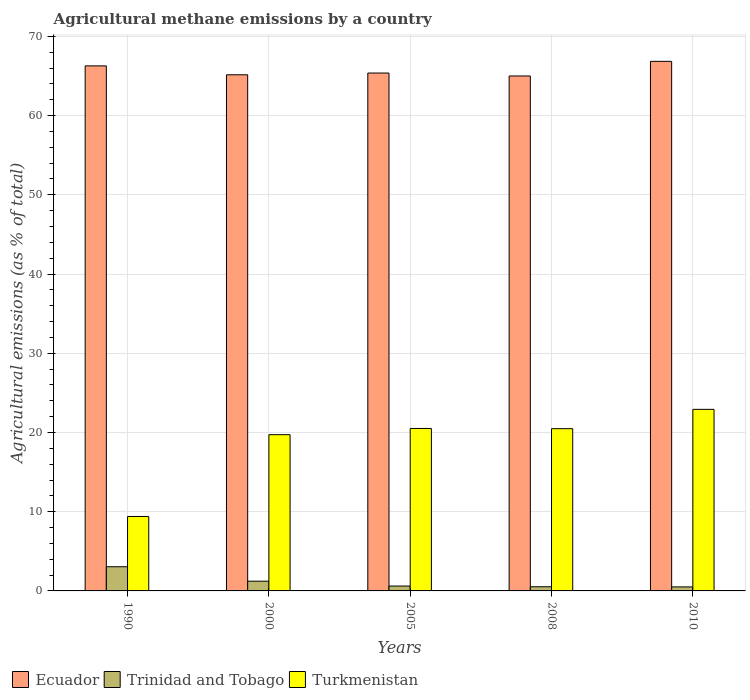How many groups of bars are there?
Offer a very short reply. 5. Are the number of bars on each tick of the X-axis equal?
Your response must be concise. Yes. What is the amount of agricultural methane emitted in Turkmenistan in 1990?
Your answer should be very brief. 9.4. Across all years, what is the maximum amount of agricultural methane emitted in Turkmenistan?
Ensure brevity in your answer.  22.92. Across all years, what is the minimum amount of agricultural methane emitted in Trinidad and Tobago?
Your answer should be very brief. 0.51. In which year was the amount of agricultural methane emitted in Trinidad and Tobago maximum?
Offer a very short reply. 1990. What is the total amount of agricultural methane emitted in Trinidad and Tobago in the graph?
Your answer should be compact. 5.93. What is the difference between the amount of agricultural methane emitted in Trinidad and Tobago in 2000 and that in 2008?
Keep it short and to the point. 0.7. What is the difference between the amount of agricultural methane emitted in Trinidad and Tobago in 2000 and the amount of agricultural methane emitted in Turkmenistan in 2005?
Provide a succinct answer. -19.28. What is the average amount of agricultural methane emitted in Trinidad and Tobago per year?
Provide a succinct answer. 1.19. In the year 2008, what is the difference between the amount of agricultural methane emitted in Turkmenistan and amount of agricultural methane emitted in Trinidad and Tobago?
Make the answer very short. 19.95. What is the ratio of the amount of agricultural methane emitted in Turkmenistan in 2000 to that in 2010?
Your answer should be compact. 0.86. Is the amount of agricultural methane emitted in Trinidad and Tobago in 2008 less than that in 2010?
Your response must be concise. No. What is the difference between the highest and the second highest amount of agricultural methane emitted in Turkmenistan?
Offer a very short reply. 2.41. What is the difference between the highest and the lowest amount of agricultural methane emitted in Ecuador?
Provide a succinct answer. 1.85. Is the sum of the amount of agricultural methane emitted in Trinidad and Tobago in 1990 and 2000 greater than the maximum amount of agricultural methane emitted in Turkmenistan across all years?
Your answer should be very brief. No. What does the 3rd bar from the left in 2000 represents?
Your response must be concise. Turkmenistan. What does the 3rd bar from the right in 2000 represents?
Keep it short and to the point. Ecuador. Is it the case that in every year, the sum of the amount of agricultural methane emitted in Trinidad and Tobago and amount of agricultural methane emitted in Ecuador is greater than the amount of agricultural methane emitted in Turkmenistan?
Provide a short and direct response. Yes. How many bars are there?
Your response must be concise. 15. How many years are there in the graph?
Your answer should be very brief. 5. What is the difference between two consecutive major ticks on the Y-axis?
Your answer should be very brief. 10. Are the values on the major ticks of Y-axis written in scientific E-notation?
Your response must be concise. No. Does the graph contain any zero values?
Offer a very short reply. No. Does the graph contain grids?
Provide a short and direct response. Yes. How many legend labels are there?
Give a very brief answer. 3. What is the title of the graph?
Your response must be concise. Agricultural methane emissions by a country. Does "Tonga" appear as one of the legend labels in the graph?
Provide a succinct answer. No. What is the label or title of the Y-axis?
Keep it short and to the point. Agricultural emissions (as % of total). What is the Agricultural emissions (as % of total) of Ecuador in 1990?
Offer a very short reply. 66.27. What is the Agricultural emissions (as % of total) in Trinidad and Tobago in 1990?
Your answer should be compact. 3.05. What is the Agricultural emissions (as % of total) in Turkmenistan in 1990?
Keep it short and to the point. 9.4. What is the Agricultural emissions (as % of total) in Ecuador in 2000?
Your answer should be compact. 65.15. What is the Agricultural emissions (as % of total) of Trinidad and Tobago in 2000?
Ensure brevity in your answer.  1.23. What is the Agricultural emissions (as % of total) of Turkmenistan in 2000?
Ensure brevity in your answer.  19.72. What is the Agricultural emissions (as % of total) in Ecuador in 2005?
Provide a short and direct response. 65.37. What is the Agricultural emissions (as % of total) in Trinidad and Tobago in 2005?
Provide a succinct answer. 0.62. What is the Agricultural emissions (as % of total) of Turkmenistan in 2005?
Give a very brief answer. 20.51. What is the Agricultural emissions (as % of total) in Ecuador in 2008?
Your answer should be very brief. 65. What is the Agricultural emissions (as % of total) in Trinidad and Tobago in 2008?
Offer a terse response. 0.53. What is the Agricultural emissions (as % of total) of Turkmenistan in 2008?
Offer a very short reply. 20.48. What is the Agricultural emissions (as % of total) of Ecuador in 2010?
Provide a short and direct response. 66.85. What is the Agricultural emissions (as % of total) of Trinidad and Tobago in 2010?
Ensure brevity in your answer.  0.51. What is the Agricultural emissions (as % of total) of Turkmenistan in 2010?
Offer a terse response. 22.92. Across all years, what is the maximum Agricultural emissions (as % of total) of Ecuador?
Your answer should be very brief. 66.85. Across all years, what is the maximum Agricultural emissions (as % of total) in Trinidad and Tobago?
Your answer should be compact. 3.05. Across all years, what is the maximum Agricultural emissions (as % of total) of Turkmenistan?
Offer a very short reply. 22.92. Across all years, what is the minimum Agricultural emissions (as % of total) in Ecuador?
Offer a terse response. 65. Across all years, what is the minimum Agricultural emissions (as % of total) of Trinidad and Tobago?
Your response must be concise. 0.51. Across all years, what is the minimum Agricultural emissions (as % of total) in Turkmenistan?
Ensure brevity in your answer.  9.4. What is the total Agricultural emissions (as % of total) of Ecuador in the graph?
Provide a succinct answer. 328.64. What is the total Agricultural emissions (as % of total) in Trinidad and Tobago in the graph?
Provide a short and direct response. 5.93. What is the total Agricultural emissions (as % of total) of Turkmenistan in the graph?
Give a very brief answer. 93.02. What is the difference between the Agricultural emissions (as % of total) in Ecuador in 1990 and that in 2000?
Your answer should be very brief. 1.12. What is the difference between the Agricultural emissions (as % of total) in Trinidad and Tobago in 1990 and that in 2000?
Provide a succinct answer. 1.82. What is the difference between the Agricultural emissions (as % of total) of Turkmenistan in 1990 and that in 2000?
Give a very brief answer. -10.32. What is the difference between the Agricultural emissions (as % of total) of Ecuador in 1990 and that in 2005?
Your response must be concise. 0.9. What is the difference between the Agricultural emissions (as % of total) of Trinidad and Tobago in 1990 and that in 2005?
Your response must be concise. 2.44. What is the difference between the Agricultural emissions (as % of total) in Turkmenistan in 1990 and that in 2005?
Your answer should be very brief. -11.11. What is the difference between the Agricultural emissions (as % of total) in Ecuador in 1990 and that in 2008?
Ensure brevity in your answer.  1.27. What is the difference between the Agricultural emissions (as % of total) of Trinidad and Tobago in 1990 and that in 2008?
Offer a very short reply. 2.53. What is the difference between the Agricultural emissions (as % of total) in Turkmenistan in 1990 and that in 2008?
Make the answer very short. -11.08. What is the difference between the Agricultural emissions (as % of total) of Ecuador in 1990 and that in 2010?
Your response must be concise. -0.57. What is the difference between the Agricultural emissions (as % of total) of Trinidad and Tobago in 1990 and that in 2010?
Your answer should be very brief. 2.55. What is the difference between the Agricultural emissions (as % of total) in Turkmenistan in 1990 and that in 2010?
Your answer should be very brief. -13.52. What is the difference between the Agricultural emissions (as % of total) of Ecuador in 2000 and that in 2005?
Your response must be concise. -0.22. What is the difference between the Agricultural emissions (as % of total) of Trinidad and Tobago in 2000 and that in 2005?
Keep it short and to the point. 0.61. What is the difference between the Agricultural emissions (as % of total) of Turkmenistan in 2000 and that in 2005?
Offer a very short reply. -0.79. What is the difference between the Agricultural emissions (as % of total) in Ecuador in 2000 and that in 2008?
Ensure brevity in your answer.  0.15. What is the difference between the Agricultural emissions (as % of total) of Trinidad and Tobago in 2000 and that in 2008?
Offer a terse response. 0.7. What is the difference between the Agricultural emissions (as % of total) of Turkmenistan in 2000 and that in 2008?
Give a very brief answer. -0.76. What is the difference between the Agricultural emissions (as % of total) of Ecuador in 2000 and that in 2010?
Your response must be concise. -1.7. What is the difference between the Agricultural emissions (as % of total) of Trinidad and Tobago in 2000 and that in 2010?
Offer a terse response. 0.72. What is the difference between the Agricultural emissions (as % of total) in Turkmenistan in 2000 and that in 2010?
Give a very brief answer. -3.2. What is the difference between the Agricultural emissions (as % of total) of Ecuador in 2005 and that in 2008?
Give a very brief answer. 0.37. What is the difference between the Agricultural emissions (as % of total) in Trinidad and Tobago in 2005 and that in 2008?
Give a very brief answer. 0.09. What is the difference between the Agricultural emissions (as % of total) in Turkmenistan in 2005 and that in 2008?
Keep it short and to the point. 0.03. What is the difference between the Agricultural emissions (as % of total) in Ecuador in 2005 and that in 2010?
Keep it short and to the point. -1.48. What is the difference between the Agricultural emissions (as % of total) in Trinidad and Tobago in 2005 and that in 2010?
Your answer should be compact. 0.11. What is the difference between the Agricultural emissions (as % of total) in Turkmenistan in 2005 and that in 2010?
Make the answer very short. -2.41. What is the difference between the Agricultural emissions (as % of total) in Ecuador in 2008 and that in 2010?
Offer a very short reply. -1.85. What is the difference between the Agricultural emissions (as % of total) in Trinidad and Tobago in 2008 and that in 2010?
Provide a succinct answer. 0.02. What is the difference between the Agricultural emissions (as % of total) in Turkmenistan in 2008 and that in 2010?
Give a very brief answer. -2.44. What is the difference between the Agricultural emissions (as % of total) in Ecuador in 1990 and the Agricultural emissions (as % of total) in Trinidad and Tobago in 2000?
Your answer should be very brief. 65.04. What is the difference between the Agricultural emissions (as % of total) in Ecuador in 1990 and the Agricultural emissions (as % of total) in Turkmenistan in 2000?
Your response must be concise. 46.55. What is the difference between the Agricultural emissions (as % of total) in Trinidad and Tobago in 1990 and the Agricultural emissions (as % of total) in Turkmenistan in 2000?
Make the answer very short. -16.67. What is the difference between the Agricultural emissions (as % of total) of Ecuador in 1990 and the Agricultural emissions (as % of total) of Trinidad and Tobago in 2005?
Offer a terse response. 65.66. What is the difference between the Agricultural emissions (as % of total) in Ecuador in 1990 and the Agricultural emissions (as % of total) in Turkmenistan in 2005?
Offer a terse response. 45.77. What is the difference between the Agricultural emissions (as % of total) of Trinidad and Tobago in 1990 and the Agricultural emissions (as % of total) of Turkmenistan in 2005?
Offer a terse response. -17.46. What is the difference between the Agricultural emissions (as % of total) in Ecuador in 1990 and the Agricultural emissions (as % of total) in Trinidad and Tobago in 2008?
Offer a very short reply. 65.75. What is the difference between the Agricultural emissions (as % of total) of Ecuador in 1990 and the Agricultural emissions (as % of total) of Turkmenistan in 2008?
Your answer should be compact. 45.8. What is the difference between the Agricultural emissions (as % of total) in Trinidad and Tobago in 1990 and the Agricultural emissions (as % of total) in Turkmenistan in 2008?
Your response must be concise. -17.43. What is the difference between the Agricultural emissions (as % of total) in Ecuador in 1990 and the Agricultural emissions (as % of total) in Trinidad and Tobago in 2010?
Your response must be concise. 65.77. What is the difference between the Agricultural emissions (as % of total) in Ecuador in 1990 and the Agricultural emissions (as % of total) in Turkmenistan in 2010?
Your response must be concise. 43.36. What is the difference between the Agricultural emissions (as % of total) in Trinidad and Tobago in 1990 and the Agricultural emissions (as % of total) in Turkmenistan in 2010?
Your answer should be compact. -19.87. What is the difference between the Agricultural emissions (as % of total) in Ecuador in 2000 and the Agricultural emissions (as % of total) in Trinidad and Tobago in 2005?
Provide a short and direct response. 64.53. What is the difference between the Agricultural emissions (as % of total) in Ecuador in 2000 and the Agricultural emissions (as % of total) in Turkmenistan in 2005?
Provide a short and direct response. 44.64. What is the difference between the Agricultural emissions (as % of total) in Trinidad and Tobago in 2000 and the Agricultural emissions (as % of total) in Turkmenistan in 2005?
Your answer should be very brief. -19.28. What is the difference between the Agricultural emissions (as % of total) in Ecuador in 2000 and the Agricultural emissions (as % of total) in Trinidad and Tobago in 2008?
Ensure brevity in your answer.  64.63. What is the difference between the Agricultural emissions (as % of total) in Ecuador in 2000 and the Agricultural emissions (as % of total) in Turkmenistan in 2008?
Make the answer very short. 44.67. What is the difference between the Agricultural emissions (as % of total) in Trinidad and Tobago in 2000 and the Agricultural emissions (as % of total) in Turkmenistan in 2008?
Your answer should be very brief. -19.25. What is the difference between the Agricultural emissions (as % of total) in Ecuador in 2000 and the Agricultural emissions (as % of total) in Trinidad and Tobago in 2010?
Keep it short and to the point. 64.64. What is the difference between the Agricultural emissions (as % of total) in Ecuador in 2000 and the Agricultural emissions (as % of total) in Turkmenistan in 2010?
Offer a terse response. 42.23. What is the difference between the Agricultural emissions (as % of total) in Trinidad and Tobago in 2000 and the Agricultural emissions (as % of total) in Turkmenistan in 2010?
Give a very brief answer. -21.69. What is the difference between the Agricultural emissions (as % of total) of Ecuador in 2005 and the Agricultural emissions (as % of total) of Trinidad and Tobago in 2008?
Provide a short and direct response. 64.85. What is the difference between the Agricultural emissions (as % of total) in Ecuador in 2005 and the Agricultural emissions (as % of total) in Turkmenistan in 2008?
Your response must be concise. 44.89. What is the difference between the Agricultural emissions (as % of total) in Trinidad and Tobago in 2005 and the Agricultural emissions (as % of total) in Turkmenistan in 2008?
Offer a very short reply. -19.86. What is the difference between the Agricultural emissions (as % of total) in Ecuador in 2005 and the Agricultural emissions (as % of total) in Trinidad and Tobago in 2010?
Your answer should be very brief. 64.86. What is the difference between the Agricultural emissions (as % of total) of Ecuador in 2005 and the Agricultural emissions (as % of total) of Turkmenistan in 2010?
Give a very brief answer. 42.45. What is the difference between the Agricultural emissions (as % of total) of Trinidad and Tobago in 2005 and the Agricultural emissions (as % of total) of Turkmenistan in 2010?
Provide a short and direct response. -22.3. What is the difference between the Agricultural emissions (as % of total) of Ecuador in 2008 and the Agricultural emissions (as % of total) of Trinidad and Tobago in 2010?
Keep it short and to the point. 64.49. What is the difference between the Agricultural emissions (as % of total) in Ecuador in 2008 and the Agricultural emissions (as % of total) in Turkmenistan in 2010?
Provide a succinct answer. 42.08. What is the difference between the Agricultural emissions (as % of total) in Trinidad and Tobago in 2008 and the Agricultural emissions (as % of total) in Turkmenistan in 2010?
Offer a very short reply. -22.39. What is the average Agricultural emissions (as % of total) of Ecuador per year?
Give a very brief answer. 65.73. What is the average Agricultural emissions (as % of total) in Trinidad and Tobago per year?
Keep it short and to the point. 1.19. What is the average Agricultural emissions (as % of total) in Turkmenistan per year?
Your response must be concise. 18.6. In the year 1990, what is the difference between the Agricultural emissions (as % of total) of Ecuador and Agricultural emissions (as % of total) of Trinidad and Tobago?
Your response must be concise. 63.22. In the year 1990, what is the difference between the Agricultural emissions (as % of total) in Ecuador and Agricultural emissions (as % of total) in Turkmenistan?
Make the answer very short. 56.88. In the year 1990, what is the difference between the Agricultural emissions (as % of total) in Trinidad and Tobago and Agricultural emissions (as % of total) in Turkmenistan?
Your answer should be compact. -6.35. In the year 2000, what is the difference between the Agricultural emissions (as % of total) of Ecuador and Agricultural emissions (as % of total) of Trinidad and Tobago?
Provide a succinct answer. 63.92. In the year 2000, what is the difference between the Agricultural emissions (as % of total) of Ecuador and Agricultural emissions (as % of total) of Turkmenistan?
Offer a terse response. 45.43. In the year 2000, what is the difference between the Agricultural emissions (as % of total) of Trinidad and Tobago and Agricultural emissions (as % of total) of Turkmenistan?
Give a very brief answer. -18.49. In the year 2005, what is the difference between the Agricultural emissions (as % of total) of Ecuador and Agricultural emissions (as % of total) of Trinidad and Tobago?
Offer a very short reply. 64.76. In the year 2005, what is the difference between the Agricultural emissions (as % of total) of Ecuador and Agricultural emissions (as % of total) of Turkmenistan?
Offer a terse response. 44.86. In the year 2005, what is the difference between the Agricultural emissions (as % of total) in Trinidad and Tobago and Agricultural emissions (as % of total) in Turkmenistan?
Provide a short and direct response. -19.89. In the year 2008, what is the difference between the Agricultural emissions (as % of total) in Ecuador and Agricultural emissions (as % of total) in Trinidad and Tobago?
Keep it short and to the point. 64.48. In the year 2008, what is the difference between the Agricultural emissions (as % of total) of Ecuador and Agricultural emissions (as % of total) of Turkmenistan?
Keep it short and to the point. 44.52. In the year 2008, what is the difference between the Agricultural emissions (as % of total) of Trinidad and Tobago and Agricultural emissions (as % of total) of Turkmenistan?
Provide a succinct answer. -19.95. In the year 2010, what is the difference between the Agricultural emissions (as % of total) in Ecuador and Agricultural emissions (as % of total) in Trinidad and Tobago?
Keep it short and to the point. 66.34. In the year 2010, what is the difference between the Agricultural emissions (as % of total) of Ecuador and Agricultural emissions (as % of total) of Turkmenistan?
Give a very brief answer. 43.93. In the year 2010, what is the difference between the Agricultural emissions (as % of total) in Trinidad and Tobago and Agricultural emissions (as % of total) in Turkmenistan?
Offer a terse response. -22.41. What is the ratio of the Agricultural emissions (as % of total) in Ecuador in 1990 to that in 2000?
Your answer should be compact. 1.02. What is the ratio of the Agricultural emissions (as % of total) in Trinidad and Tobago in 1990 to that in 2000?
Make the answer very short. 2.48. What is the ratio of the Agricultural emissions (as % of total) in Turkmenistan in 1990 to that in 2000?
Your answer should be compact. 0.48. What is the ratio of the Agricultural emissions (as % of total) of Ecuador in 1990 to that in 2005?
Your response must be concise. 1.01. What is the ratio of the Agricultural emissions (as % of total) in Trinidad and Tobago in 1990 to that in 2005?
Provide a succinct answer. 4.95. What is the ratio of the Agricultural emissions (as % of total) in Turkmenistan in 1990 to that in 2005?
Your response must be concise. 0.46. What is the ratio of the Agricultural emissions (as % of total) of Ecuador in 1990 to that in 2008?
Your answer should be very brief. 1.02. What is the ratio of the Agricultural emissions (as % of total) of Trinidad and Tobago in 1990 to that in 2008?
Your answer should be very brief. 5.81. What is the ratio of the Agricultural emissions (as % of total) of Turkmenistan in 1990 to that in 2008?
Your answer should be very brief. 0.46. What is the ratio of the Agricultural emissions (as % of total) of Trinidad and Tobago in 1990 to that in 2010?
Your response must be concise. 6.03. What is the ratio of the Agricultural emissions (as % of total) of Turkmenistan in 1990 to that in 2010?
Make the answer very short. 0.41. What is the ratio of the Agricultural emissions (as % of total) of Trinidad and Tobago in 2000 to that in 2005?
Give a very brief answer. 2. What is the ratio of the Agricultural emissions (as % of total) in Turkmenistan in 2000 to that in 2005?
Your answer should be very brief. 0.96. What is the ratio of the Agricultural emissions (as % of total) of Ecuador in 2000 to that in 2008?
Your answer should be compact. 1. What is the ratio of the Agricultural emissions (as % of total) in Trinidad and Tobago in 2000 to that in 2008?
Provide a short and direct response. 2.34. What is the ratio of the Agricultural emissions (as % of total) of Turkmenistan in 2000 to that in 2008?
Your answer should be compact. 0.96. What is the ratio of the Agricultural emissions (as % of total) of Ecuador in 2000 to that in 2010?
Give a very brief answer. 0.97. What is the ratio of the Agricultural emissions (as % of total) of Trinidad and Tobago in 2000 to that in 2010?
Your answer should be very brief. 2.43. What is the ratio of the Agricultural emissions (as % of total) of Turkmenistan in 2000 to that in 2010?
Offer a terse response. 0.86. What is the ratio of the Agricultural emissions (as % of total) of Ecuador in 2005 to that in 2008?
Your answer should be very brief. 1.01. What is the ratio of the Agricultural emissions (as % of total) in Trinidad and Tobago in 2005 to that in 2008?
Make the answer very short. 1.17. What is the ratio of the Agricultural emissions (as % of total) in Turkmenistan in 2005 to that in 2008?
Offer a terse response. 1. What is the ratio of the Agricultural emissions (as % of total) in Ecuador in 2005 to that in 2010?
Give a very brief answer. 0.98. What is the ratio of the Agricultural emissions (as % of total) of Trinidad and Tobago in 2005 to that in 2010?
Your answer should be very brief. 1.22. What is the ratio of the Agricultural emissions (as % of total) of Turkmenistan in 2005 to that in 2010?
Give a very brief answer. 0.89. What is the ratio of the Agricultural emissions (as % of total) in Ecuador in 2008 to that in 2010?
Provide a short and direct response. 0.97. What is the ratio of the Agricultural emissions (as % of total) in Trinidad and Tobago in 2008 to that in 2010?
Give a very brief answer. 1.04. What is the ratio of the Agricultural emissions (as % of total) in Turkmenistan in 2008 to that in 2010?
Provide a short and direct response. 0.89. What is the difference between the highest and the second highest Agricultural emissions (as % of total) of Ecuador?
Provide a succinct answer. 0.57. What is the difference between the highest and the second highest Agricultural emissions (as % of total) in Trinidad and Tobago?
Ensure brevity in your answer.  1.82. What is the difference between the highest and the second highest Agricultural emissions (as % of total) of Turkmenistan?
Ensure brevity in your answer.  2.41. What is the difference between the highest and the lowest Agricultural emissions (as % of total) in Ecuador?
Ensure brevity in your answer.  1.85. What is the difference between the highest and the lowest Agricultural emissions (as % of total) in Trinidad and Tobago?
Keep it short and to the point. 2.55. What is the difference between the highest and the lowest Agricultural emissions (as % of total) in Turkmenistan?
Make the answer very short. 13.52. 